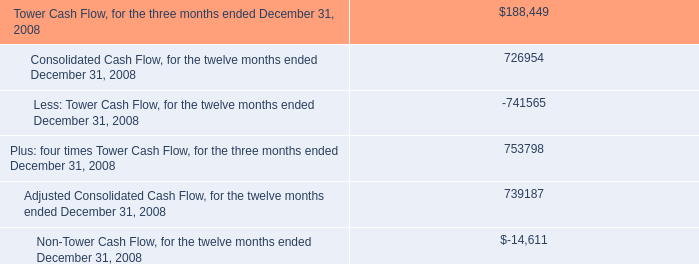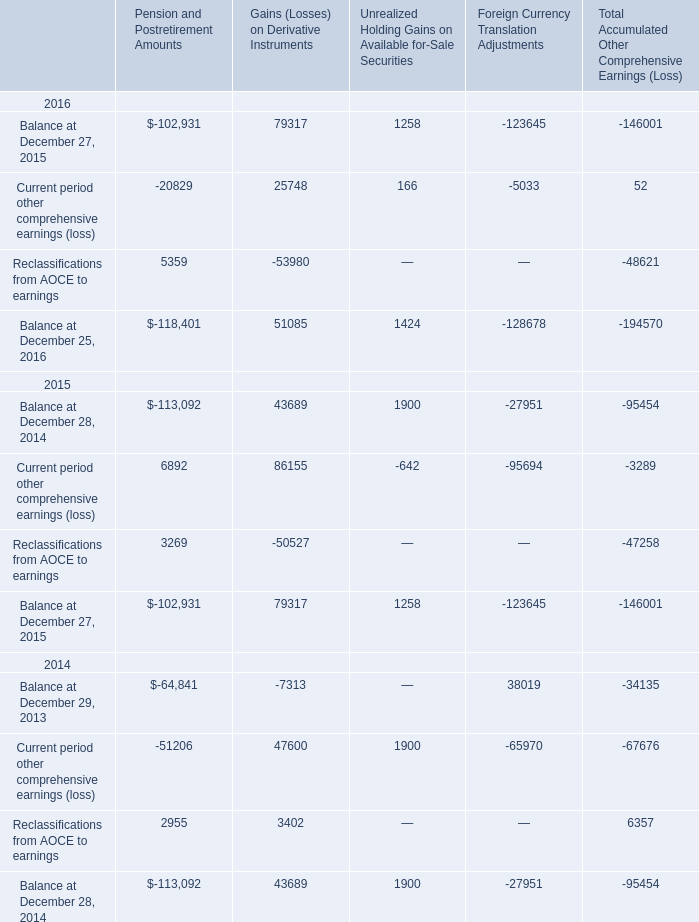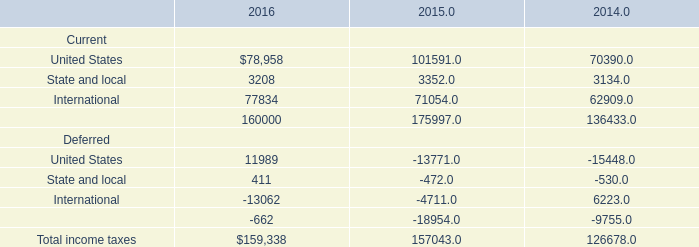What is the sum of Pension and Postretirement Amounts, Gains (Losses) on Derivative Instruments and Unrealized Holding Gains on Available for-Sale Securities in Balance at December 27, 2015 ? 
Computations: ((-102931 + 79317) + 1258)
Answer: -22356.0. 